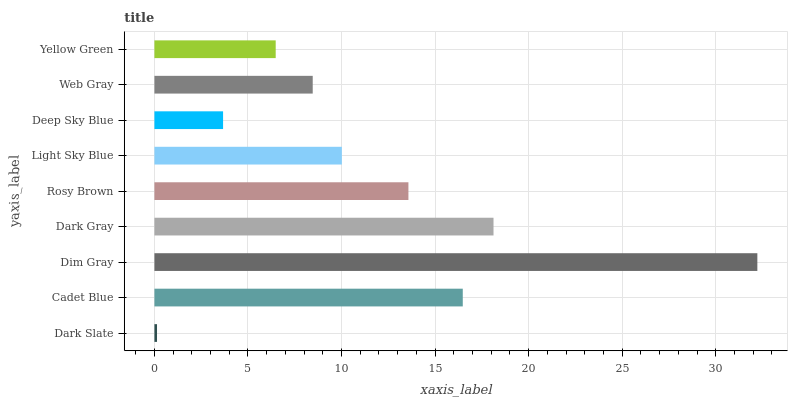Is Dark Slate the minimum?
Answer yes or no. Yes. Is Dim Gray the maximum?
Answer yes or no. Yes. Is Cadet Blue the minimum?
Answer yes or no. No. Is Cadet Blue the maximum?
Answer yes or no. No. Is Cadet Blue greater than Dark Slate?
Answer yes or no. Yes. Is Dark Slate less than Cadet Blue?
Answer yes or no. Yes. Is Dark Slate greater than Cadet Blue?
Answer yes or no. No. Is Cadet Blue less than Dark Slate?
Answer yes or no. No. Is Light Sky Blue the high median?
Answer yes or no. Yes. Is Light Sky Blue the low median?
Answer yes or no. Yes. Is Dark Slate the high median?
Answer yes or no. No. Is Dark Slate the low median?
Answer yes or no. No. 